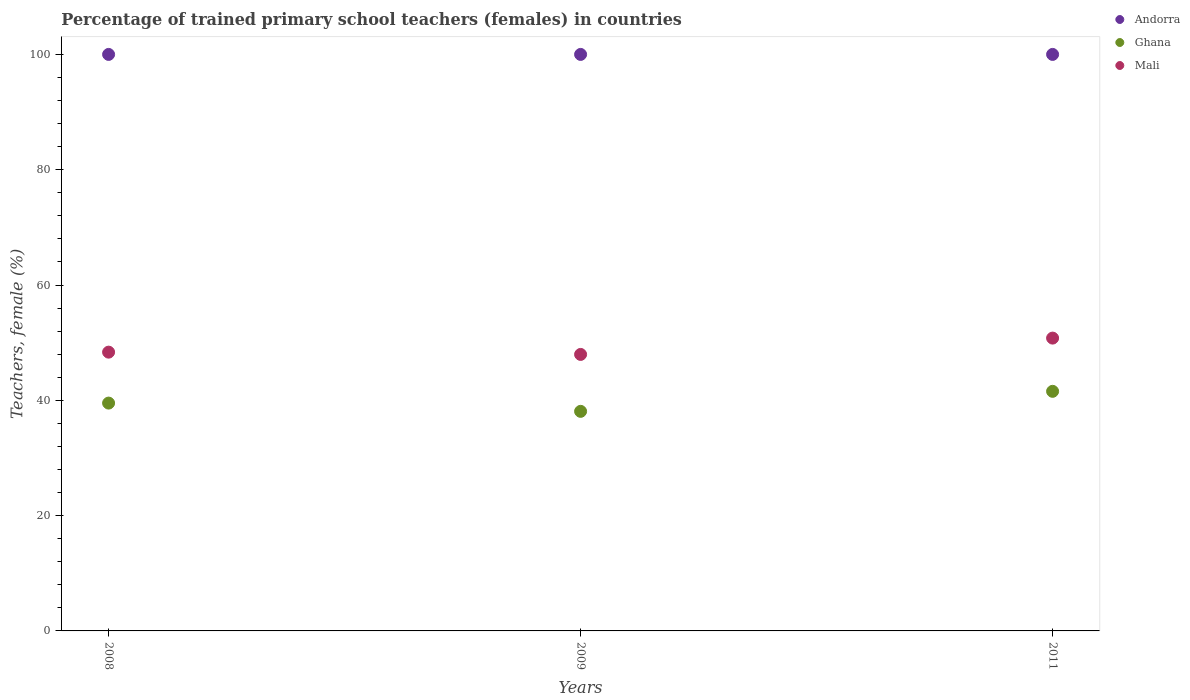How many different coloured dotlines are there?
Your answer should be compact. 3. Is the number of dotlines equal to the number of legend labels?
Provide a short and direct response. Yes. What is the percentage of trained primary school teachers (females) in Ghana in 2009?
Provide a succinct answer. 38.09. Across all years, what is the maximum percentage of trained primary school teachers (females) in Andorra?
Your response must be concise. 100. Across all years, what is the minimum percentage of trained primary school teachers (females) in Mali?
Make the answer very short. 47.96. In which year was the percentage of trained primary school teachers (females) in Ghana maximum?
Your response must be concise. 2011. In which year was the percentage of trained primary school teachers (females) in Andorra minimum?
Offer a terse response. 2008. What is the total percentage of trained primary school teachers (females) in Ghana in the graph?
Give a very brief answer. 119.17. What is the difference between the percentage of trained primary school teachers (females) in Andorra in 2008 and that in 2009?
Keep it short and to the point. 0. What is the difference between the percentage of trained primary school teachers (females) in Andorra in 2011 and the percentage of trained primary school teachers (females) in Mali in 2008?
Keep it short and to the point. 51.64. What is the average percentage of trained primary school teachers (females) in Ghana per year?
Provide a short and direct response. 39.72. In the year 2009, what is the difference between the percentage of trained primary school teachers (females) in Mali and percentage of trained primary school teachers (females) in Ghana?
Give a very brief answer. 9.87. What is the ratio of the percentage of trained primary school teachers (females) in Ghana in 2008 to that in 2009?
Provide a short and direct response. 1.04. Is the percentage of trained primary school teachers (females) in Andorra in 2008 less than that in 2009?
Make the answer very short. No. Is the difference between the percentage of trained primary school teachers (females) in Mali in 2008 and 2011 greater than the difference between the percentage of trained primary school teachers (females) in Ghana in 2008 and 2011?
Offer a terse response. No. What is the difference between the highest and the second highest percentage of trained primary school teachers (females) in Ghana?
Keep it short and to the point. 2.04. In how many years, is the percentage of trained primary school teachers (females) in Mali greater than the average percentage of trained primary school teachers (females) in Mali taken over all years?
Give a very brief answer. 1. Is the sum of the percentage of trained primary school teachers (females) in Mali in 2009 and 2011 greater than the maximum percentage of trained primary school teachers (females) in Ghana across all years?
Offer a terse response. Yes. Is the percentage of trained primary school teachers (females) in Ghana strictly greater than the percentage of trained primary school teachers (females) in Andorra over the years?
Offer a terse response. No. Is the percentage of trained primary school teachers (females) in Mali strictly less than the percentage of trained primary school teachers (females) in Ghana over the years?
Keep it short and to the point. No. How many years are there in the graph?
Ensure brevity in your answer.  3. Are the values on the major ticks of Y-axis written in scientific E-notation?
Make the answer very short. No. Does the graph contain any zero values?
Make the answer very short. No. Does the graph contain grids?
Your answer should be very brief. No. Where does the legend appear in the graph?
Make the answer very short. Top right. How many legend labels are there?
Make the answer very short. 3. How are the legend labels stacked?
Your response must be concise. Vertical. What is the title of the graph?
Your answer should be compact. Percentage of trained primary school teachers (females) in countries. Does "Serbia" appear as one of the legend labels in the graph?
Your answer should be compact. No. What is the label or title of the Y-axis?
Make the answer very short. Teachers, female (%). What is the Teachers, female (%) in Andorra in 2008?
Your answer should be compact. 100. What is the Teachers, female (%) in Ghana in 2008?
Provide a succinct answer. 39.52. What is the Teachers, female (%) of Mali in 2008?
Your answer should be very brief. 48.36. What is the Teachers, female (%) in Ghana in 2009?
Offer a very short reply. 38.09. What is the Teachers, female (%) in Mali in 2009?
Ensure brevity in your answer.  47.96. What is the Teachers, female (%) in Ghana in 2011?
Provide a succinct answer. 41.56. What is the Teachers, female (%) of Mali in 2011?
Ensure brevity in your answer.  50.79. Across all years, what is the maximum Teachers, female (%) in Ghana?
Your answer should be very brief. 41.56. Across all years, what is the maximum Teachers, female (%) in Mali?
Keep it short and to the point. 50.79. Across all years, what is the minimum Teachers, female (%) in Andorra?
Give a very brief answer. 100. Across all years, what is the minimum Teachers, female (%) in Ghana?
Offer a terse response. 38.09. Across all years, what is the minimum Teachers, female (%) of Mali?
Offer a very short reply. 47.96. What is the total Teachers, female (%) of Andorra in the graph?
Offer a very short reply. 300. What is the total Teachers, female (%) of Ghana in the graph?
Your answer should be very brief. 119.17. What is the total Teachers, female (%) in Mali in the graph?
Provide a short and direct response. 147.11. What is the difference between the Teachers, female (%) in Andorra in 2008 and that in 2009?
Offer a very short reply. 0. What is the difference between the Teachers, female (%) in Ghana in 2008 and that in 2009?
Keep it short and to the point. 1.43. What is the difference between the Teachers, female (%) in Mali in 2008 and that in 2009?
Your answer should be very brief. 0.4. What is the difference between the Teachers, female (%) in Ghana in 2008 and that in 2011?
Make the answer very short. -2.04. What is the difference between the Teachers, female (%) of Mali in 2008 and that in 2011?
Offer a terse response. -2.44. What is the difference between the Teachers, female (%) in Andorra in 2009 and that in 2011?
Your response must be concise. 0. What is the difference between the Teachers, female (%) in Ghana in 2009 and that in 2011?
Make the answer very short. -3.47. What is the difference between the Teachers, female (%) of Mali in 2009 and that in 2011?
Provide a short and direct response. -2.83. What is the difference between the Teachers, female (%) in Andorra in 2008 and the Teachers, female (%) in Ghana in 2009?
Your response must be concise. 61.91. What is the difference between the Teachers, female (%) in Andorra in 2008 and the Teachers, female (%) in Mali in 2009?
Offer a very short reply. 52.04. What is the difference between the Teachers, female (%) of Ghana in 2008 and the Teachers, female (%) of Mali in 2009?
Your response must be concise. -8.44. What is the difference between the Teachers, female (%) in Andorra in 2008 and the Teachers, female (%) in Ghana in 2011?
Provide a succinct answer. 58.44. What is the difference between the Teachers, female (%) of Andorra in 2008 and the Teachers, female (%) of Mali in 2011?
Your response must be concise. 49.21. What is the difference between the Teachers, female (%) of Ghana in 2008 and the Teachers, female (%) of Mali in 2011?
Provide a short and direct response. -11.27. What is the difference between the Teachers, female (%) of Andorra in 2009 and the Teachers, female (%) of Ghana in 2011?
Offer a very short reply. 58.44. What is the difference between the Teachers, female (%) in Andorra in 2009 and the Teachers, female (%) in Mali in 2011?
Give a very brief answer. 49.21. What is the difference between the Teachers, female (%) of Ghana in 2009 and the Teachers, female (%) of Mali in 2011?
Provide a short and direct response. -12.71. What is the average Teachers, female (%) of Ghana per year?
Offer a terse response. 39.72. What is the average Teachers, female (%) of Mali per year?
Your answer should be compact. 49.04. In the year 2008, what is the difference between the Teachers, female (%) of Andorra and Teachers, female (%) of Ghana?
Give a very brief answer. 60.48. In the year 2008, what is the difference between the Teachers, female (%) in Andorra and Teachers, female (%) in Mali?
Offer a terse response. 51.64. In the year 2008, what is the difference between the Teachers, female (%) of Ghana and Teachers, female (%) of Mali?
Provide a succinct answer. -8.84. In the year 2009, what is the difference between the Teachers, female (%) of Andorra and Teachers, female (%) of Ghana?
Ensure brevity in your answer.  61.91. In the year 2009, what is the difference between the Teachers, female (%) in Andorra and Teachers, female (%) in Mali?
Your answer should be very brief. 52.04. In the year 2009, what is the difference between the Teachers, female (%) in Ghana and Teachers, female (%) in Mali?
Offer a terse response. -9.87. In the year 2011, what is the difference between the Teachers, female (%) in Andorra and Teachers, female (%) in Ghana?
Give a very brief answer. 58.44. In the year 2011, what is the difference between the Teachers, female (%) in Andorra and Teachers, female (%) in Mali?
Your response must be concise. 49.21. In the year 2011, what is the difference between the Teachers, female (%) in Ghana and Teachers, female (%) in Mali?
Your answer should be very brief. -9.23. What is the ratio of the Teachers, female (%) of Andorra in 2008 to that in 2009?
Your answer should be very brief. 1. What is the ratio of the Teachers, female (%) of Ghana in 2008 to that in 2009?
Give a very brief answer. 1.04. What is the ratio of the Teachers, female (%) of Mali in 2008 to that in 2009?
Provide a succinct answer. 1.01. What is the ratio of the Teachers, female (%) of Ghana in 2008 to that in 2011?
Make the answer very short. 0.95. What is the ratio of the Teachers, female (%) of Andorra in 2009 to that in 2011?
Offer a very short reply. 1. What is the ratio of the Teachers, female (%) in Ghana in 2009 to that in 2011?
Your response must be concise. 0.92. What is the ratio of the Teachers, female (%) in Mali in 2009 to that in 2011?
Your response must be concise. 0.94. What is the difference between the highest and the second highest Teachers, female (%) of Ghana?
Provide a succinct answer. 2.04. What is the difference between the highest and the second highest Teachers, female (%) of Mali?
Offer a terse response. 2.44. What is the difference between the highest and the lowest Teachers, female (%) in Ghana?
Offer a very short reply. 3.47. What is the difference between the highest and the lowest Teachers, female (%) of Mali?
Your response must be concise. 2.83. 